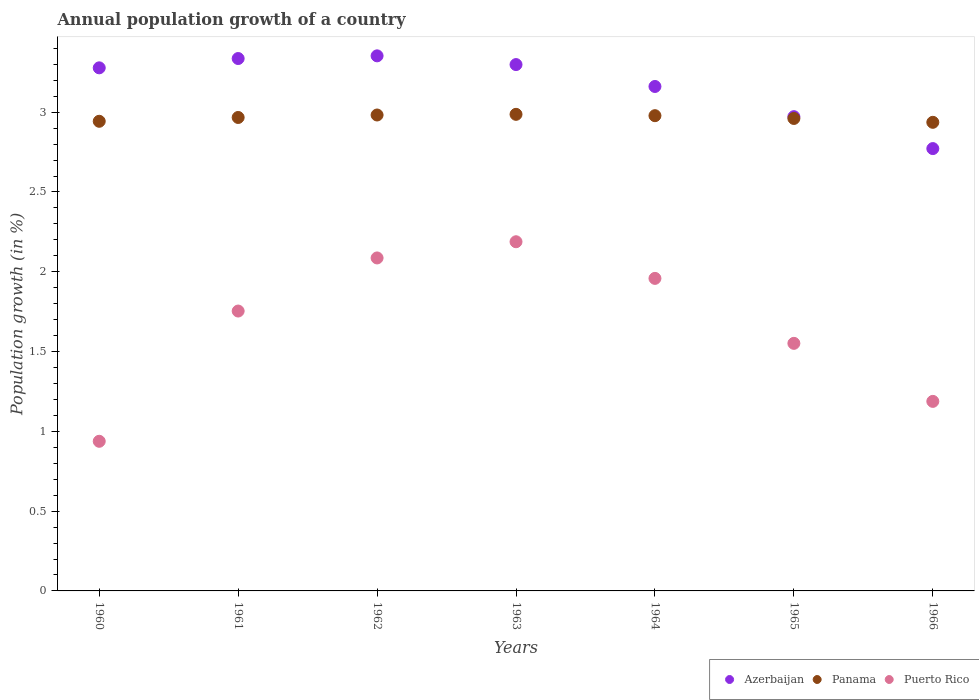How many different coloured dotlines are there?
Offer a terse response. 3. What is the annual population growth in Azerbaijan in 1964?
Keep it short and to the point. 3.16. Across all years, what is the maximum annual population growth in Puerto Rico?
Provide a short and direct response. 2.19. Across all years, what is the minimum annual population growth in Azerbaijan?
Provide a short and direct response. 2.77. In which year was the annual population growth in Panama minimum?
Your response must be concise. 1966. What is the total annual population growth in Azerbaijan in the graph?
Ensure brevity in your answer.  22.17. What is the difference between the annual population growth in Puerto Rico in 1962 and that in 1964?
Your answer should be compact. 0.13. What is the difference between the annual population growth in Azerbaijan in 1960 and the annual population growth in Panama in 1965?
Make the answer very short. 0.32. What is the average annual population growth in Azerbaijan per year?
Your answer should be compact. 3.17. In the year 1963, what is the difference between the annual population growth in Panama and annual population growth in Azerbaijan?
Provide a short and direct response. -0.31. In how many years, is the annual population growth in Panama greater than 1.2 %?
Keep it short and to the point. 7. What is the ratio of the annual population growth in Azerbaijan in 1962 to that in 1963?
Your answer should be compact. 1.02. Is the difference between the annual population growth in Panama in 1961 and 1962 greater than the difference between the annual population growth in Azerbaijan in 1961 and 1962?
Make the answer very short. Yes. What is the difference between the highest and the second highest annual population growth in Puerto Rico?
Provide a succinct answer. 0.1. What is the difference between the highest and the lowest annual population growth in Puerto Rico?
Offer a terse response. 1.25. In how many years, is the annual population growth in Panama greater than the average annual population growth in Panama taken over all years?
Your answer should be compact. 4. Is the sum of the annual population growth in Puerto Rico in 1961 and 1966 greater than the maximum annual population growth in Azerbaijan across all years?
Your answer should be compact. No. Does the annual population growth in Puerto Rico monotonically increase over the years?
Keep it short and to the point. No. How many dotlines are there?
Keep it short and to the point. 3. How many years are there in the graph?
Your response must be concise. 7. What is the difference between two consecutive major ticks on the Y-axis?
Make the answer very short. 0.5. Does the graph contain grids?
Ensure brevity in your answer.  No. Where does the legend appear in the graph?
Ensure brevity in your answer.  Bottom right. What is the title of the graph?
Keep it short and to the point. Annual population growth of a country. What is the label or title of the Y-axis?
Keep it short and to the point. Population growth (in %). What is the Population growth (in %) in Azerbaijan in 1960?
Keep it short and to the point. 3.28. What is the Population growth (in %) of Panama in 1960?
Provide a succinct answer. 2.94. What is the Population growth (in %) in Puerto Rico in 1960?
Make the answer very short. 0.94. What is the Population growth (in %) of Azerbaijan in 1961?
Your answer should be very brief. 3.34. What is the Population growth (in %) of Panama in 1961?
Ensure brevity in your answer.  2.97. What is the Population growth (in %) of Puerto Rico in 1961?
Your response must be concise. 1.75. What is the Population growth (in %) of Azerbaijan in 1962?
Offer a terse response. 3.35. What is the Population growth (in %) of Panama in 1962?
Provide a succinct answer. 2.98. What is the Population growth (in %) in Puerto Rico in 1962?
Make the answer very short. 2.09. What is the Population growth (in %) in Azerbaijan in 1963?
Your answer should be compact. 3.3. What is the Population growth (in %) of Panama in 1963?
Offer a terse response. 2.99. What is the Population growth (in %) in Puerto Rico in 1963?
Provide a succinct answer. 2.19. What is the Population growth (in %) of Azerbaijan in 1964?
Offer a very short reply. 3.16. What is the Population growth (in %) in Panama in 1964?
Your response must be concise. 2.98. What is the Population growth (in %) of Puerto Rico in 1964?
Offer a very short reply. 1.96. What is the Population growth (in %) of Azerbaijan in 1965?
Offer a terse response. 2.97. What is the Population growth (in %) in Panama in 1965?
Ensure brevity in your answer.  2.96. What is the Population growth (in %) in Puerto Rico in 1965?
Your answer should be very brief. 1.55. What is the Population growth (in %) in Azerbaijan in 1966?
Provide a succinct answer. 2.77. What is the Population growth (in %) in Panama in 1966?
Your answer should be compact. 2.94. What is the Population growth (in %) in Puerto Rico in 1966?
Ensure brevity in your answer.  1.19. Across all years, what is the maximum Population growth (in %) in Azerbaijan?
Give a very brief answer. 3.35. Across all years, what is the maximum Population growth (in %) in Panama?
Give a very brief answer. 2.99. Across all years, what is the maximum Population growth (in %) of Puerto Rico?
Provide a succinct answer. 2.19. Across all years, what is the minimum Population growth (in %) of Azerbaijan?
Your answer should be compact. 2.77. Across all years, what is the minimum Population growth (in %) of Panama?
Your answer should be compact. 2.94. Across all years, what is the minimum Population growth (in %) in Puerto Rico?
Offer a very short reply. 0.94. What is the total Population growth (in %) of Azerbaijan in the graph?
Provide a succinct answer. 22.17. What is the total Population growth (in %) in Panama in the graph?
Give a very brief answer. 20.75. What is the total Population growth (in %) in Puerto Rico in the graph?
Offer a very short reply. 11.66. What is the difference between the Population growth (in %) of Azerbaijan in 1960 and that in 1961?
Your answer should be compact. -0.06. What is the difference between the Population growth (in %) in Panama in 1960 and that in 1961?
Your answer should be very brief. -0.02. What is the difference between the Population growth (in %) in Puerto Rico in 1960 and that in 1961?
Your answer should be very brief. -0.82. What is the difference between the Population growth (in %) in Azerbaijan in 1960 and that in 1962?
Provide a succinct answer. -0.08. What is the difference between the Population growth (in %) in Panama in 1960 and that in 1962?
Your answer should be very brief. -0.04. What is the difference between the Population growth (in %) of Puerto Rico in 1960 and that in 1962?
Ensure brevity in your answer.  -1.15. What is the difference between the Population growth (in %) of Azerbaijan in 1960 and that in 1963?
Ensure brevity in your answer.  -0.02. What is the difference between the Population growth (in %) of Panama in 1960 and that in 1963?
Your answer should be compact. -0.04. What is the difference between the Population growth (in %) of Puerto Rico in 1960 and that in 1963?
Ensure brevity in your answer.  -1.25. What is the difference between the Population growth (in %) of Azerbaijan in 1960 and that in 1964?
Keep it short and to the point. 0.12. What is the difference between the Population growth (in %) of Panama in 1960 and that in 1964?
Provide a short and direct response. -0.04. What is the difference between the Population growth (in %) of Puerto Rico in 1960 and that in 1964?
Ensure brevity in your answer.  -1.02. What is the difference between the Population growth (in %) of Azerbaijan in 1960 and that in 1965?
Make the answer very short. 0.31. What is the difference between the Population growth (in %) of Panama in 1960 and that in 1965?
Your answer should be very brief. -0.02. What is the difference between the Population growth (in %) of Puerto Rico in 1960 and that in 1965?
Provide a succinct answer. -0.61. What is the difference between the Population growth (in %) of Azerbaijan in 1960 and that in 1966?
Offer a terse response. 0.51. What is the difference between the Population growth (in %) in Panama in 1960 and that in 1966?
Give a very brief answer. 0.01. What is the difference between the Population growth (in %) in Puerto Rico in 1960 and that in 1966?
Keep it short and to the point. -0.25. What is the difference between the Population growth (in %) of Azerbaijan in 1961 and that in 1962?
Offer a very short reply. -0.02. What is the difference between the Population growth (in %) of Panama in 1961 and that in 1962?
Your answer should be compact. -0.02. What is the difference between the Population growth (in %) in Puerto Rico in 1961 and that in 1962?
Offer a very short reply. -0.33. What is the difference between the Population growth (in %) in Azerbaijan in 1961 and that in 1963?
Make the answer very short. 0.04. What is the difference between the Population growth (in %) in Panama in 1961 and that in 1963?
Provide a succinct answer. -0.02. What is the difference between the Population growth (in %) of Puerto Rico in 1961 and that in 1963?
Give a very brief answer. -0.43. What is the difference between the Population growth (in %) in Azerbaijan in 1961 and that in 1964?
Give a very brief answer. 0.18. What is the difference between the Population growth (in %) of Panama in 1961 and that in 1964?
Your answer should be very brief. -0.01. What is the difference between the Population growth (in %) in Puerto Rico in 1961 and that in 1964?
Offer a terse response. -0.2. What is the difference between the Population growth (in %) of Azerbaijan in 1961 and that in 1965?
Your answer should be compact. 0.36. What is the difference between the Population growth (in %) of Panama in 1961 and that in 1965?
Your answer should be compact. 0.01. What is the difference between the Population growth (in %) of Puerto Rico in 1961 and that in 1965?
Give a very brief answer. 0.2. What is the difference between the Population growth (in %) in Azerbaijan in 1961 and that in 1966?
Offer a terse response. 0.56. What is the difference between the Population growth (in %) of Panama in 1961 and that in 1966?
Your answer should be very brief. 0.03. What is the difference between the Population growth (in %) in Puerto Rico in 1961 and that in 1966?
Make the answer very short. 0.57. What is the difference between the Population growth (in %) of Azerbaijan in 1962 and that in 1963?
Ensure brevity in your answer.  0.05. What is the difference between the Population growth (in %) of Panama in 1962 and that in 1963?
Your answer should be compact. -0. What is the difference between the Population growth (in %) in Puerto Rico in 1962 and that in 1963?
Provide a short and direct response. -0.1. What is the difference between the Population growth (in %) in Azerbaijan in 1962 and that in 1964?
Provide a succinct answer. 0.19. What is the difference between the Population growth (in %) in Panama in 1962 and that in 1964?
Offer a terse response. 0. What is the difference between the Population growth (in %) of Puerto Rico in 1962 and that in 1964?
Offer a terse response. 0.13. What is the difference between the Population growth (in %) of Azerbaijan in 1962 and that in 1965?
Provide a short and direct response. 0.38. What is the difference between the Population growth (in %) of Panama in 1962 and that in 1965?
Give a very brief answer. 0.02. What is the difference between the Population growth (in %) of Puerto Rico in 1962 and that in 1965?
Your response must be concise. 0.54. What is the difference between the Population growth (in %) of Azerbaijan in 1962 and that in 1966?
Keep it short and to the point. 0.58. What is the difference between the Population growth (in %) in Panama in 1962 and that in 1966?
Make the answer very short. 0.05. What is the difference between the Population growth (in %) of Puerto Rico in 1962 and that in 1966?
Your answer should be compact. 0.9. What is the difference between the Population growth (in %) in Azerbaijan in 1963 and that in 1964?
Offer a terse response. 0.14. What is the difference between the Population growth (in %) of Panama in 1963 and that in 1964?
Your answer should be compact. 0.01. What is the difference between the Population growth (in %) in Puerto Rico in 1963 and that in 1964?
Your response must be concise. 0.23. What is the difference between the Population growth (in %) in Azerbaijan in 1963 and that in 1965?
Keep it short and to the point. 0.33. What is the difference between the Population growth (in %) in Panama in 1963 and that in 1965?
Provide a short and direct response. 0.03. What is the difference between the Population growth (in %) in Puerto Rico in 1963 and that in 1965?
Give a very brief answer. 0.64. What is the difference between the Population growth (in %) of Azerbaijan in 1963 and that in 1966?
Give a very brief answer. 0.53. What is the difference between the Population growth (in %) in Azerbaijan in 1964 and that in 1965?
Keep it short and to the point. 0.19. What is the difference between the Population growth (in %) in Panama in 1964 and that in 1965?
Give a very brief answer. 0.02. What is the difference between the Population growth (in %) of Puerto Rico in 1964 and that in 1965?
Give a very brief answer. 0.41. What is the difference between the Population growth (in %) in Azerbaijan in 1964 and that in 1966?
Your answer should be compact. 0.39. What is the difference between the Population growth (in %) of Panama in 1964 and that in 1966?
Your response must be concise. 0.04. What is the difference between the Population growth (in %) of Puerto Rico in 1964 and that in 1966?
Your answer should be very brief. 0.77. What is the difference between the Population growth (in %) of Panama in 1965 and that in 1966?
Give a very brief answer. 0.02. What is the difference between the Population growth (in %) in Puerto Rico in 1965 and that in 1966?
Give a very brief answer. 0.36. What is the difference between the Population growth (in %) of Azerbaijan in 1960 and the Population growth (in %) of Panama in 1961?
Your answer should be compact. 0.31. What is the difference between the Population growth (in %) of Azerbaijan in 1960 and the Population growth (in %) of Puerto Rico in 1961?
Make the answer very short. 1.52. What is the difference between the Population growth (in %) of Panama in 1960 and the Population growth (in %) of Puerto Rico in 1961?
Provide a succinct answer. 1.19. What is the difference between the Population growth (in %) of Azerbaijan in 1960 and the Population growth (in %) of Panama in 1962?
Provide a short and direct response. 0.3. What is the difference between the Population growth (in %) in Azerbaijan in 1960 and the Population growth (in %) in Puerto Rico in 1962?
Offer a terse response. 1.19. What is the difference between the Population growth (in %) of Panama in 1960 and the Population growth (in %) of Puerto Rico in 1962?
Give a very brief answer. 0.86. What is the difference between the Population growth (in %) in Azerbaijan in 1960 and the Population growth (in %) in Panama in 1963?
Your answer should be very brief. 0.29. What is the difference between the Population growth (in %) of Azerbaijan in 1960 and the Population growth (in %) of Puerto Rico in 1963?
Your response must be concise. 1.09. What is the difference between the Population growth (in %) in Panama in 1960 and the Population growth (in %) in Puerto Rico in 1963?
Offer a terse response. 0.75. What is the difference between the Population growth (in %) of Azerbaijan in 1960 and the Population growth (in %) of Panama in 1964?
Give a very brief answer. 0.3. What is the difference between the Population growth (in %) in Azerbaijan in 1960 and the Population growth (in %) in Puerto Rico in 1964?
Ensure brevity in your answer.  1.32. What is the difference between the Population growth (in %) of Panama in 1960 and the Population growth (in %) of Puerto Rico in 1964?
Offer a terse response. 0.98. What is the difference between the Population growth (in %) in Azerbaijan in 1960 and the Population growth (in %) in Panama in 1965?
Offer a very short reply. 0.32. What is the difference between the Population growth (in %) in Azerbaijan in 1960 and the Population growth (in %) in Puerto Rico in 1965?
Your response must be concise. 1.73. What is the difference between the Population growth (in %) of Panama in 1960 and the Population growth (in %) of Puerto Rico in 1965?
Keep it short and to the point. 1.39. What is the difference between the Population growth (in %) of Azerbaijan in 1960 and the Population growth (in %) of Panama in 1966?
Your answer should be compact. 0.34. What is the difference between the Population growth (in %) of Azerbaijan in 1960 and the Population growth (in %) of Puerto Rico in 1966?
Provide a short and direct response. 2.09. What is the difference between the Population growth (in %) in Panama in 1960 and the Population growth (in %) in Puerto Rico in 1966?
Provide a succinct answer. 1.76. What is the difference between the Population growth (in %) in Azerbaijan in 1961 and the Population growth (in %) in Panama in 1962?
Provide a succinct answer. 0.35. What is the difference between the Population growth (in %) of Azerbaijan in 1961 and the Population growth (in %) of Puerto Rico in 1962?
Ensure brevity in your answer.  1.25. What is the difference between the Population growth (in %) of Panama in 1961 and the Population growth (in %) of Puerto Rico in 1962?
Your answer should be compact. 0.88. What is the difference between the Population growth (in %) of Azerbaijan in 1961 and the Population growth (in %) of Panama in 1963?
Provide a short and direct response. 0.35. What is the difference between the Population growth (in %) of Azerbaijan in 1961 and the Population growth (in %) of Puerto Rico in 1963?
Give a very brief answer. 1.15. What is the difference between the Population growth (in %) in Panama in 1961 and the Population growth (in %) in Puerto Rico in 1963?
Offer a terse response. 0.78. What is the difference between the Population growth (in %) in Azerbaijan in 1961 and the Population growth (in %) in Panama in 1964?
Make the answer very short. 0.36. What is the difference between the Population growth (in %) in Azerbaijan in 1961 and the Population growth (in %) in Puerto Rico in 1964?
Make the answer very short. 1.38. What is the difference between the Population growth (in %) in Panama in 1961 and the Population growth (in %) in Puerto Rico in 1964?
Provide a succinct answer. 1.01. What is the difference between the Population growth (in %) in Azerbaijan in 1961 and the Population growth (in %) in Panama in 1965?
Your response must be concise. 0.38. What is the difference between the Population growth (in %) of Azerbaijan in 1961 and the Population growth (in %) of Puerto Rico in 1965?
Ensure brevity in your answer.  1.78. What is the difference between the Population growth (in %) of Panama in 1961 and the Population growth (in %) of Puerto Rico in 1965?
Provide a succinct answer. 1.42. What is the difference between the Population growth (in %) in Azerbaijan in 1961 and the Population growth (in %) in Panama in 1966?
Give a very brief answer. 0.4. What is the difference between the Population growth (in %) of Azerbaijan in 1961 and the Population growth (in %) of Puerto Rico in 1966?
Your answer should be very brief. 2.15. What is the difference between the Population growth (in %) of Panama in 1961 and the Population growth (in %) of Puerto Rico in 1966?
Your response must be concise. 1.78. What is the difference between the Population growth (in %) in Azerbaijan in 1962 and the Population growth (in %) in Panama in 1963?
Ensure brevity in your answer.  0.37. What is the difference between the Population growth (in %) of Azerbaijan in 1962 and the Population growth (in %) of Puerto Rico in 1963?
Your response must be concise. 1.17. What is the difference between the Population growth (in %) in Panama in 1962 and the Population growth (in %) in Puerto Rico in 1963?
Keep it short and to the point. 0.79. What is the difference between the Population growth (in %) in Azerbaijan in 1962 and the Population growth (in %) in Panama in 1964?
Offer a very short reply. 0.37. What is the difference between the Population growth (in %) of Azerbaijan in 1962 and the Population growth (in %) of Puerto Rico in 1964?
Offer a very short reply. 1.39. What is the difference between the Population growth (in %) in Panama in 1962 and the Population growth (in %) in Puerto Rico in 1964?
Your answer should be compact. 1.02. What is the difference between the Population growth (in %) of Azerbaijan in 1962 and the Population growth (in %) of Panama in 1965?
Your response must be concise. 0.39. What is the difference between the Population growth (in %) in Azerbaijan in 1962 and the Population growth (in %) in Puerto Rico in 1965?
Keep it short and to the point. 1.8. What is the difference between the Population growth (in %) of Panama in 1962 and the Population growth (in %) of Puerto Rico in 1965?
Provide a succinct answer. 1.43. What is the difference between the Population growth (in %) of Azerbaijan in 1962 and the Population growth (in %) of Panama in 1966?
Offer a terse response. 0.42. What is the difference between the Population growth (in %) of Azerbaijan in 1962 and the Population growth (in %) of Puerto Rico in 1966?
Give a very brief answer. 2.17. What is the difference between the Population growth (in %) in Panama in 1962 and the Population growth (in %) in Puerto Rico in 1966?
Your answer should be very brief. 1.79. What is the difference between the Population growth (in %) of Azerbaijan in 1963 and the Population growth (in %) of Panama in 1964?
Make the answer very short. 0.32. What is the difference between the Population growth (in %) in Azerbaijan in 1963 and the Population growth (in %) in Puerto Rico in 1964?
Offer a terse response. 1.34. What is the difference between the Population growth (in %) in Panama in 1963 and the Population growth (in %) in Puerto Rico in 1964?
Your answer should be very brief. 1.03. What is the difference between the Population growth (in %) in Azerbaijan in 1963 and the Population growth (in %) in Panama in 1965?
Your answer should be very brief. 0.34. What is the difference between the Population growth (in %) of Azerbaijan in 1963 and the Population growth (in %) of Puerto Rico in 1965?
Provide a succinct answer. 1.75. What is the difference between the Population growth (in %) of Panama in 1963 and the Population growth (in %) of Puerto Rico in 1965?
Your answer should be compact. 1.44. What is the difference between the Population growth (in %) in Azerbaijan in 1963 and the Population growth (in %) in Panama in 1966?
Offer a terse response. 0.36. What is the difference between the Population growth (in %) in Azerbaijan in 1963 and the Population growth (in %) in Puerto Rico in 1966?
Your answer should be compact. 2.11. What is the difference between the Population growth (in %) in Panama in 1963 and the Population growth (in %) in Puerto Rico in 1966?
Offer a terse response. 1.8. What is the difference between the Population growth (in %) in Azerbaijan in 1964 and the Population growth (in %) in Panama in 1965?
Ensure brevity in your answer.  0.2. What is the difference between the Population growth (in %) of Azerbaijan in 1964 and the Population growth (in %) of Puerto Rico in 1965?
Make the answer very short. 1.61. What is the difference between the Population growth (in %) of Panama in 1964 and the Population growth (in %) of Puerto Rico in 1965?
Ensure brevity in your answer.  1.43. What is the difference between the Population growth (in %) in Azerbaijan in 1964 and the Population growth (in %) in Panama in 1966?
Your answer should be very brief. 0.22. What is the difference between the Population growth (in %) in Azerbaijan in 1964 and the Population growth (in %) in Puerto Rico in 1966?
Ensure brevity in your answer.  1.97. What is the difference between the Population growth (in %) of Panama in 1964 and the Population growth (in %) of Puerto Rico in 1966?
Offer a very short reply. 1.79. What is the difference between the Population growth (in %) of Azerbaijan in 1965 and the Population growth (in %) of Panama in 1966?
Provide a succinct answer. 0.04. What is the difference between the Population growth (in %) of Azerbaijan in 1965 and the Population growth (in %) of Puerto Rico in 1966?
Give a very brief answer. 1.78. What is the difference between the Population growth (in %) of Panama in 1965 and the Population growth (in %) of Puerto Rico in 1966?
Keep it short and to the point. 1.77. What is the average Population growth (in %) in Azerbaijan per year?
Keep it short and to the point. 3.17. What is the average Population growth (in %) of Panama per year?
Offer a very short reply. 2.96. What is the average Population growth (in %) of Puerto Rico per year?
Your response must be concise. 1.67. In the year 1960, what is the difference between the Population growth (in %) of Azerbaijan and Population growth (in %) of Panama?
Your answer should be very brief. 0.33. In the year 1960, what is the difference between the Population growth (in %) in Azerbaijan and Population growth (in %) in Puerto Rico?
Your answer should be very brief. 2.34. In the year 1960, what is the difference between the Population growth (in %) of Panama and Population growth (in %) of Puerto Rico?
Your response must be concise. 2.01. In the year 1961, what is the difference between the Population growth (in %) of Azerbaijan and Population growth (in %) of Panama?
Give a very brief answer. 0.37. In the year 1961, what is the difference between the Population growth (in %) of Azerbaijan and Population growth (in %) of Puerto Rico?
Offer a terse response. 1.58. In the year 1961, what is the difference between the Population growth (in %) of Panama and Population growth (in %) of Puerto Rico?
Offer a very short reply. 1.21. In the year 1962, what is the difference between the Population growth (in %) in Azerbaijan and Population growth (in %) in Panama?
Provide a short and direct response. 0.37. In the year 1962, what is the difference between the Population growth (in %) in Azerbaijan and Population growth (in %) in Puerto Rico?
Give a very brief answer. 1.27. In the year 1962, what is the difference between the Population growth (in %) of Panama and Population growth (in %) of Puerto Rico?
Your answer should be very brief. 0.9. In the year 1963, what is the difference between the Population growth (in %) of Azerbaijan and Population growth (in %) of Panama?
Your answer should be compact. 0.31. In the year 1963, what is the difference between the Population growth (in %) in Azerbaijan and Population growth (in %) in Puerto Rico?
Offer a terse response. 1.11. In the year 1963, what is the difference between the Population growth (in %) of Panama and Population growth (in %) of Puerto Rico?
Keep it short and to the point. 0.8. In the year 1964, what is the difference between the Population growth (in %) in Azerbaijan and Population growth (in %) in Panama?
Provide a succinct answer. 0.18. In the year 1964, what is the difference between the Population growth (in %) of Azerbaijan and Population growth (in %) of Puerto Rico?
Make the answer very short. 1.2. In the year 1964, what is the difference between the Population growth (in %) of Panama and Population growth (in %) of Puerto Rico?
Your answer should be very brief. 1.02. In the year 1965, what is the difference between the Population growth (in %) of Azerbaijan and Population growth (in %) of Panama?
Ensure brevity in your answer.  0.01. In the year 1965, what is the difference between the Population growth (in %) of Azerbaijan and Population growth (in %) of Puerto Rico?
Provide a short and direct response. 1.42. In the year 1965, what is the difference between the Population growth (in %) of Panama and Population growth (in %) of Puerto Rico?
Ensure brevity in your answer.  1.41. In the year 1966, what is the difference between the Population growth (in %) in Azerbaijan and Population growth (in %) in Panama?
Give a very brief answer. -0.16. In the year 1966, what is the difference between the Population growth (in %) in Azerbaijan and Population growth (in %) in Puerto Rico?
Provide a short and direct response. 1.58. In the year 1966, what is the difference between the Population growth (in %) in Panama and Population growth (in %) in Puerto Rico?
Ensure brevity in your answer.  1.75. What is the ratio of the Population growth (in %) in Azerbaijan in 1960 to that in 1961?
Keep it short and to the point. 0.98. What is the ratio of the Population growth (in %) in Panama in 1960 to that in 1961?
Ensure brevity in your answer.  0.99. What is the ratio of the Population growth (in %) in Puerto Rico in 1960 to that in 1961?
Provide a short and direct response. 0.53. What is the ratio of the Population growth (in %) of Azerbaijan in 1960 to that in 1962?
Offer a terse response. 0.98. What is the ratio of the Population growth (in %) of Panama in 1960 to that in 1962?
Offer a very short reply. 0.99. What is the ratio of the Population growth (in %) in Puerto Rico in 1960 to that in 1962?
Your response must be concise. 0.45. What is the ratio of the Population growth (in %) of Panama in 1960 to that in 1963?
Ensure brevity in your answer.  0.99. What is the ratio of the Population growth (in %) in Puerto Rico in 1960 to that in 1963?
Keep it short and to the point. 0.43. What is the ratio of the Population growth (in %) of Panama in 1960 to that in 1964?
Your response must be concise. 0.99. What is the ratio of the Population growth (in %) in Puerto Rico in 1960 to that in 1964?
Provide a succinct answer. 0.48. What is the ratio of the Population growth (in %) of Azerbaijan in 1960 to that in 1965?
Provide a succinct answer. 1.1. What is the ratio of the Population growth (in %) of Panama in 1960 to that in 1965?
Make the answer very short. 0.99. What is the ratio of the Population growth (in %) in Puerto Rico in 1960 to that in 1965?
Offer a terse response. 0.6. What is the ratio of the Population growth (in %) in Azerbaijan in 1960 to that in 1966?
Give a very brief answer. 1.18. What is the ratio of the Population growth (in %) of Panama in 1960 to that in 1966?
Ensure brevity in your answer.  1. What is the ratio of the Population growth (in %) of Puerto Rico in 1960 to that in 1966?
Provide a short and direct response. 0.79. What is the ratio of the Population growth (in %) in Azerbaijan in 1961 to that in 1962?
Your answer should be compact. 0.99. What is the ratio of the Population growth (in %) of Puerto Rico in 1961 to that in 1962?
Make the answer very short. 0.84. What is the ratio of the Population growth (in %) of Azerbaijan in 1961 to that in 1963?
Give a very brief answer. 1.01. What is the ratio of the Population growth (in %) of Puerto Rico in 1961 to that in 1963?
Your answer should be compact. 0.8. What is the ratio of the Population growth (in %) in Azerbaijan in 1961 to that in 1964?
Offer a very short reply. 1.06. What is the ratio of the Population growth (in %) of Panama in 1961 to that in 1964?
Offer a very short reply. 1. What is the ratio of the Population growth (in %) of Puerto Rico in 1961 to that in 1964?
Offer a terse response. 0.9. What is the ratio of the Population growth (in %) in Azerbaijan in 1961 to that in 1965?
Your answer should be compact. 1.12. What is the ratio of the Population growth (in %) in Puerto Rico in 1961 to that in 1965?
Provide a succinct answer. 1.13. What is the ratio of the Population growth (in %) of Azerbaijan in 1961 to that in 1966?
Give a very brief answer. 1.2. What is the ratio of the Population growth (in %) of Panama in 1961 to that in 1966?
Offer a terse response. 1.01. What is the ratio of the Population growth (in %) of Puerto Rico in 1961 to that in 1966?
Your response must be concise. 1.48. What is the ratio of the Population growth (in %) in Azerbaijan in 1962 to that in 1963?
Your answer should be compact. 1.02. What is the ratio of the Population growth (in %) of Panama in 1962 to that in 1963?
Provide a short and direct response. 1. What is the ratio of the Population growth (in %) of Puerto Rico in 1962 to that in 1963?
Your answer should be very brief. 0.95. What is the ratio of the Population growth (in %) of Azerbaijan in 1962 to that in 1964?
Provide a short and direct response. 1.06. What is the ratio of the Population growth (in %) of Panama in 1962 to that in 1964?
Offer a very short reply. 1. What is the ratio of the Population growth (in %) of Puerto Rico in 1962 to that in 1964?
Offer a terse response. 1.07. What is the ratio of the Population growth (in %) in Azerbaijan in 1962 to that in 1965?
Your answer should be very brief. 1.13. What is the ratio of the Population growth (in %) in Panama in 1962 to that in 1965?
Provide a succinct answer. 1.01. What is the ratio of the Population growth (in %) of Puerto Rico in 1962 to that in 1965?
Keep it short and to the point. 1.34. What is the ratio of the Population growth (in %) in Azerbaijan in 1962 to that in 1966?
Keep it short and to the point. 1.21. What is the ratio of the Population growth (in %) in Panama in 1962 to that in 1966?
Keep it short and to the point. 1.02. What is the ratio of the Population growth (in %) of Puerto Rico in 1962 to that in 1966?
Provide a short and direct response. 1.76. What is the ratio of the Population growth (in %) of Azerbaijan in 1963 to that in 1964?
Keep it short and to the point. 1.04. What is the ratio of the Population growth (in %) in Puerto Rico in 1963 to that in 1964?
Your answer should be compact. 1.12. What is the ratio of the Population growth (in %) in Azerbaijan in 1963 to that in 1965?
Offer a very short reply. 1.11. What is the ratio of the Population growth (in %) of Panama in 1963 to that in 1965?
Offer a very short reply. 1.01. What is the ratio of the Population growth (in %) in Puerto Rico in 1963 to that in 1965?
Provide a short and direct response. 1.41. What is the ratio of the Population growth (in %) of Azerbaijan in 1963 to that in 1966?
Offer a very short reply. 1.19. What is the ratio of the Population growth (in %) in Puerto Rico in 1963 to that in 1966?
Make the answer very short. 1.84. What is the ratio of the Population growth (in %) in Azerbaijan in 1964 to that in 1965?
Ensure brevity in your answer.  1.06. What is the ratio of the Population growth (in %) of Panama in 1964 to that in 1965?
Your answer should be compact. 1.01. What is the ratio of the Population growth (in %) in Puerto Rico in 1964 to that in 1965?
Your answer should be very brief. 1.26. What is the ratio of the Population growth (in %) of Azerbaijan in 1964 to that in 1966?
Offer a very short reply. 1.14. What is the ratio of the Population growth (in %) in Panama in 1964 to that in 1966?
Keep it short and to the point. 1.01. What is the ratio of the Population growth (in %) in Puerto Rico in 1964 to that in 1966?
Ensure brevity in your answer.  1.65. What is the ratio of the Population growth (in %) of Azerbaijan in 1965 to that in 1966?
Give a very brief answer. 1.07. What is the ratio of the Population growth (in %) in Panama in 1965 to that in 1966?
Provide a succinct answer. 1.01. What is the ratio of the Population growth (in %) of Puerto Rico in 1965 to that in 1966?
Provide a succinct answer. 1.31. What is the difference between the highest and the second highest Population growth (in %) of Azerbaijan?
Your answer should be compact. 0.02. What is the difference between the highest and the second highest Population growth (in %) of Panama?
Make the answer very short. 0. What is the difference between the highest and the second highest Population growth (in %) in Puerto Rico?
Offer a terse response. 0.1. What is the difference between the highest and the lowest Population growth (in %) of Azerbaijan?
Provide a succinct answer. 0.58. What is the difference between the highest and the lowest Population growth (in %) in Panama?
Ensure brevity in your answer.  0.05. What is the difference between the highest and the lowest Population growth (in %) of Puerto Rico?
Your response must be concise. 1.25. 